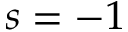Convert formula to latex. <formula><loc_0><loc_0><loc_500><loc_500>s = - 1</formula> 